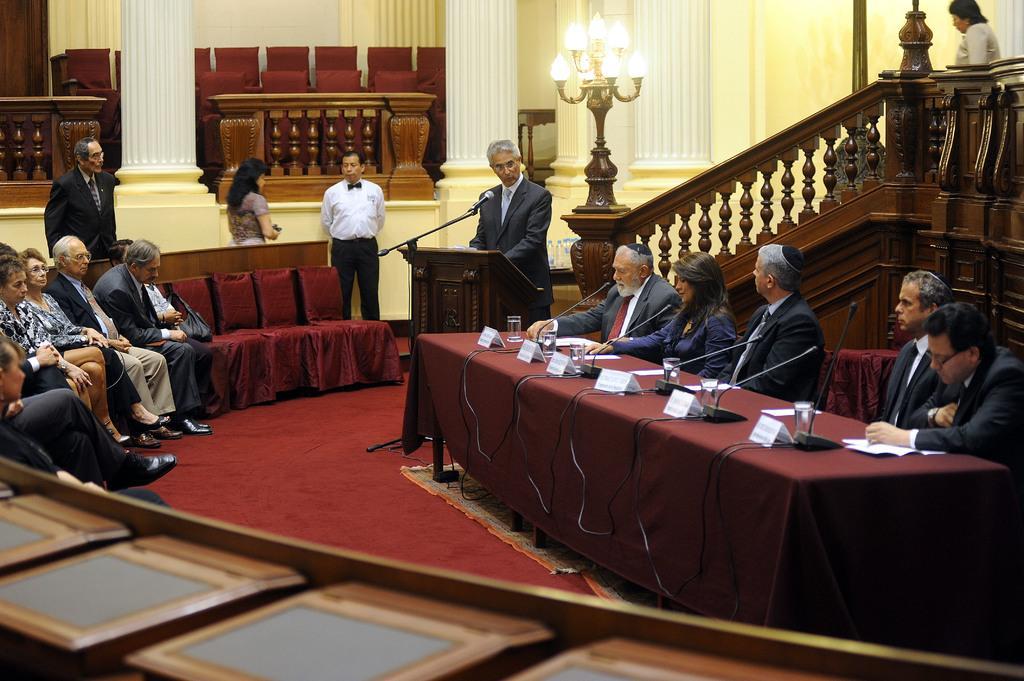Please provide a concise description of this image. In this image, we can see few people. Few are sitting and standing. Here there is a desk covered with cloth. few things and objects are placed on it. In the middle of the image, a person is standing behind the podium. Background there is a wall, pillars, chairs, railing, lights. At the bottom of the image, we can see wooden objects. 